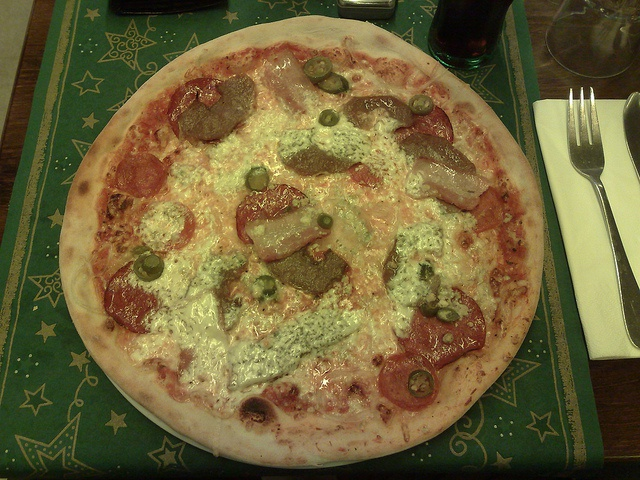Describe the objects in this image and their specific colors. I can see dining table in tan, black, olive, and darkgreen tones, pizza in olive and tan tones, cup in olive, black, and darkgreen tones, fork in olive, darkgreen, khaki, and black tones, and cup in olive, black, darkgreen, and maroon tones in this image. 